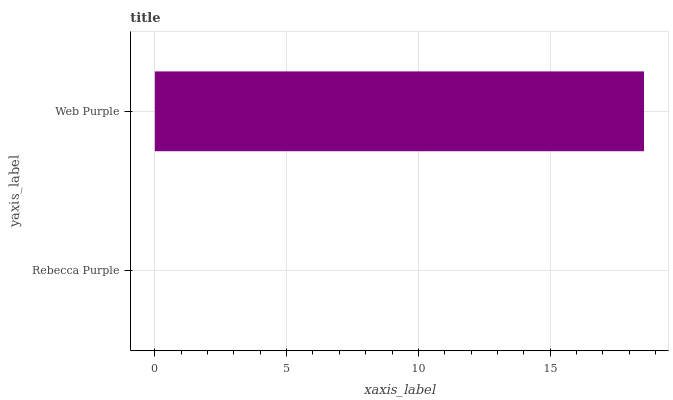Is Rebecca Purple the minimum?
Answer yes or no. Yes. Is Web Purple the maximum?
Answer yes or no. Yes. Is Web Purple the minimum?
Answer yes or no. No. Is Web Purple greater than Rebecca Purple?
Answer yes or no. Yes. Is Rebecca Purple less than Web Purple?
Answer yes or no. Yes. Is Rebecca Purple greater than Web Purple?
Answer yes or no. No. Is Web Purple less than Rebecca Purple?
Answer yes or no. No. Is Web Purple the high median?
Answer yes or no. Yes. Is Rebecca Purple the low median?
Answer yes or no. Yes. Is Rebecca Purple the high median?
Answer yes or no. No. Is Web Purple the low median?
Answer yes or no. No. 